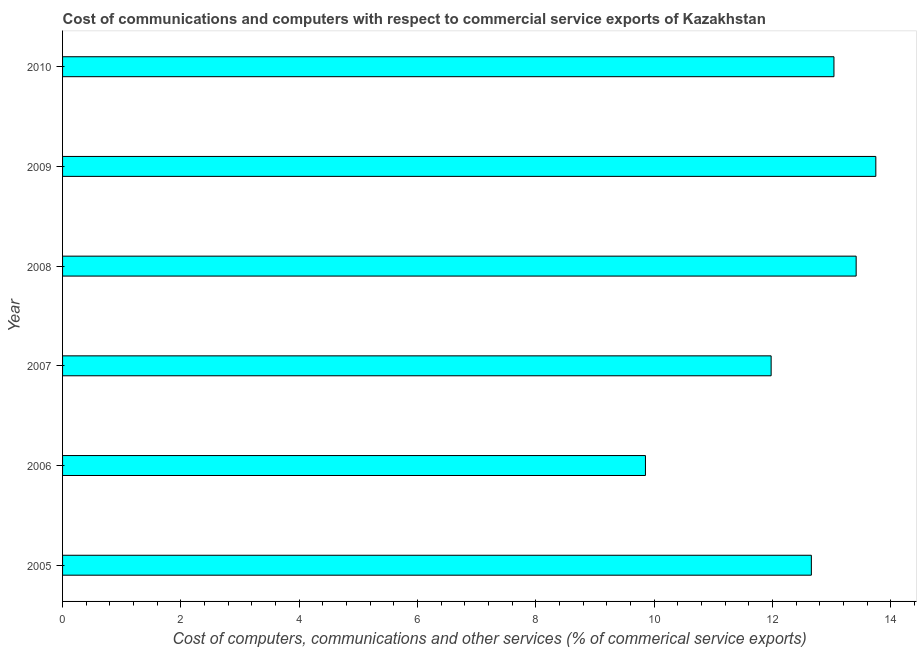What is the title of the graph?
Keep it short and to the point. Cost of communications and computers with respect to commercial service exports of Kazakhstan. What is the label or title of the X-axis?
Ensure brevity in your answer.  Cost of computers, communications and other services (% of commerical service exports). What is the  computer and other services in 2010?
Your response must be concise. 13.04. Across all years, what is the maximum  computer and other services?
Offer a terse response. 13.75. Across all years, what is the minimum cost of communications?
Ensure brevity in your answer.  9.85. What is the sum of the cost of communications?
Keep it short and to the point. 74.7. What is the difference between the  computer and other services in 2005 and 2008?
Your answer should be compact. -0.76. What is the average  computer and other services per year?
Ensure brevity in your answer.  12.45. What is the median  computer and other services?
Offer a very short reply. 12.85. What is the ratio of the  computer and other services in 2007 to that in 2008?
Offer a very short reply. 0.89. Is the cost of communications in 2006 less than that in 2010?
Your answer should be compact. Yes. Is the difference between the  computer and other services in 2009 and 2010 greater than the difference between any two years?
Provide a short and direct response. No. What is the difference between the highest and the second highest  computer and other services?
Offer a terse response. 0.33. What is the difference between the highest and the lowest cost of communications?
Your answer should be compact. 3.89. How many bars are there?
Ensure brevity in your answer.  6. Are all the bars in the graph horizontal?
Keep it short and to the point. Yes. What is the difference between two consecutive major ticks on the X-axis?
Your answer should be very brief. 2. Are the values on the major ticks of X-axis written in scientific E-notation?
Offer a terse response. No. What is the Cost of computers, communications and other services (% of commerical service exports) of 2005?
Keep it short and to the point. 12.66. What is the Cost of computers, communications and other services (% of commerical service exports) of 2006?
Give a very brief answer. 9.85. What is the Cost of computers, communications and other services (% of commerical service exports) of 2007?
Keep it short and to the point. 11.98. What is the Cost of computers, communications and other services (% of commerical service exports) of 2008?
Your answer should be compact. 13.42. What is the Cost of computers, communications and other services (% of commerical service exports) in 2009?
Keep it short and to the point. 13.75. What is the Cost of computers, communications and other services (% of commerical service exports) in 2010?
Ensure brevity in your answer.  13.04. What is the difference between the Cost of computers, communications and other services (% of commerical service exports) in 2005 and 2006?
Keep it short and to the point. 2.8. What is the difference between the Cost of computers, communications and other services (% of commerical service exports) in 2005 and 2007?
Keep it short and to the point. 0.68. What is the difference between the Cost of computers, communications and other services (% of commerical service exports) in 2005 and 2008?
Provide a short and direct response. -0.76. What is the difference between the Cost of computers, communications and other services (% of commerical service exports) in 2005 and 2009?
Offer a very short reply. -1.09. What is the difference between the Cost of computers, communications and other services (% of commerical service exports) in 2005 and 2010?
Make the answer very short. -0.38. What is the difference between the Cost of computers, communications and other services (% of commerical service exports) in 2006 and 2007?
Ensure brevity in your answer.  -2.12. What is the difference between the Cost of computers, communications and other services (% of commerical service exports) in 2006 and 2008?
Your response must be concise. -3.56. What is the difference between the Cost of computers, communications and other services (% of commerical service exports) in 2006 and 2009?
Give a very brief answer. -3.89. What is the difference between the Cost of computers, communications and other services (% of commerical service exports) in 2006 and 2010?
Offer a very short reply. -3.19. What is the difference between the Cost of computers, communications and other services (% of commerical service exports) in 2007 and 2008?
Make the answer very short. -1.44. What is the difference between the Cost of computers, communications and other services (% of commerical service exports) in 2007 and 2009?
Ensure brevity in your answer.  -1.77. What is the difference between the Cost of computers, communications and other services (% of commerical service exports) in 2007 and 2010?
Keep it short and to the point. -1.06. What is the difference between the Cost of computers, communications and other services (% of commerical service exports) in 2008 and 2009?
Offer a terse response. -0.33. What is the difference between the Cost of computers, communications and other services (% of commerical service exports) in 2008 and 2010?
Offer a very short reply. 0.38. What is the difference between the Cost of computers, communications and other services (% of commerical service exports) in 2009 and 2010?
Give a very brief answer. 0.71. What is the ratio of the Cost of computers, communications and other services (% of commerical service exports) in 2005 to that in 2006?
Make the answer very short. 1.28. What is the ratio of the Cost of computers, communications and other services (% of commerical service exports) in 2005 to that in 2007?
Your answer should be very brief. 1.06. What is the ratio of the Cost of computers, communications and other services (% of commerical service exports) in 2005 to that in 2008?
Keep it short and to the point. 0.94. What is the ratio of the Cost of computers, communications and other services (% of commerical service exports) in 2005 to that in 2009?
Offer a terse response. 0.92. What is the ratio of the Cost of computers, communications and other services (% of commerical service exports) in 2006 to that in 2007?
Your answer should be very brief. 0.82. What is the ratio of the Cost of computers, communications and other services (% of commerical service exports) in 2006 to that in 2008?
Ensure brevity in your answer.  0.73. What is the ratio of the Cost of computers, communications and other services (% of commerical service exports) in 2006 to that in 2009?
Your answer should be compact. 0.72. What is the ratio of the Cost of computers, communications and other services (% of commerical service exports) in 2006 to that in 2010?
Keep it short and to the point. 0.76. What is the ratio of the Cost of computers, communications and other services (% of commerical service exports) in 2007 to that in 2008?
Ensure brevity in your answer.  0.89. What is the ratio of the Cost of computers, communications and other services (% of commerical service exports) in 2007 to that in 2009?
Your answer should be very brief. 0.87. What is the ratio of the Cost of computers, communications and other services (% of commerical service exports) in 2007 to that in 2010?
Keep it short and to the point. 0.92. What is the ratio of the Cost of computers, communications and other services (% of commerical service exports) in 2009 to that in 2010?
Make the answer very short. 1.05. 